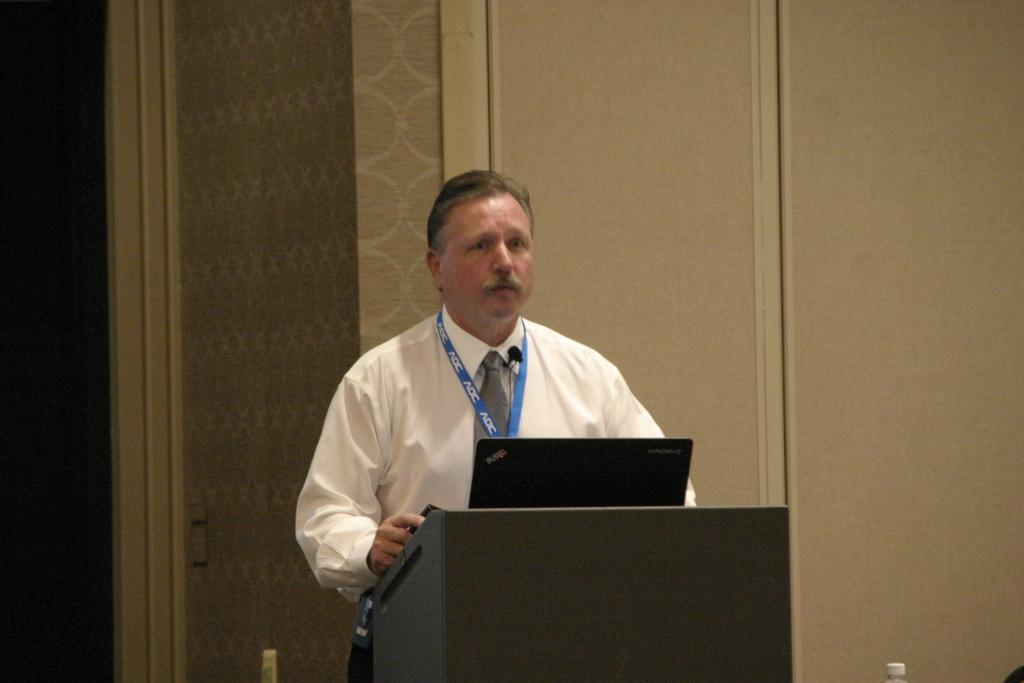What is the person in the image wearing? The person is wearing a white shirt in the image. What can be seen behind the person? The background wall is in grey color. What is the person standing in front of? The person is standing in front of a wooden stand. What object is on the wooden stand? There is a laptop on the wooden stand. What type of grip does the person have on the credit card in the image? There is no credit card present in the image, so it is not possible to determine the type of grip the person has on it. 